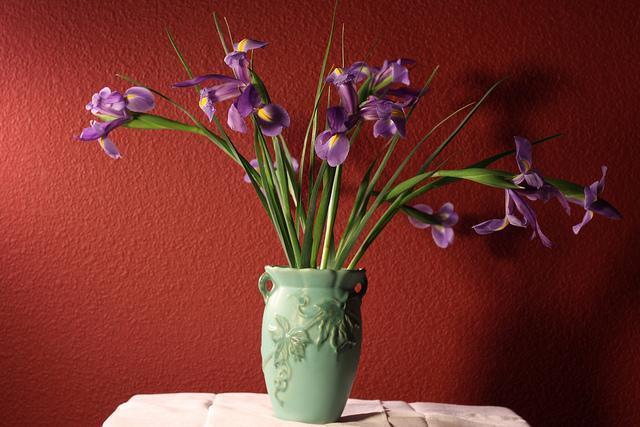How many men are wearing white in the image?
Give a very brief answer. 0. 